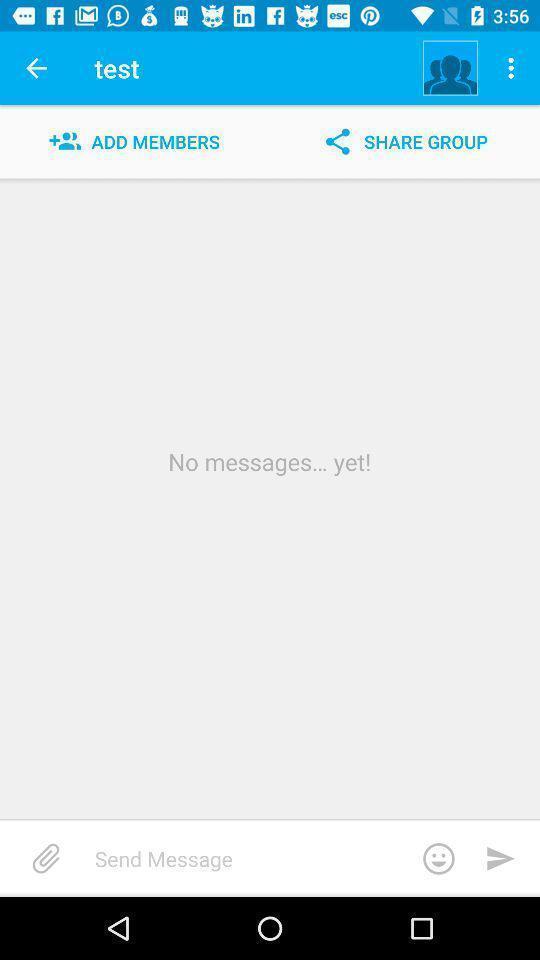Please provide a description for this image. Page displaying with add members and share option in application. 